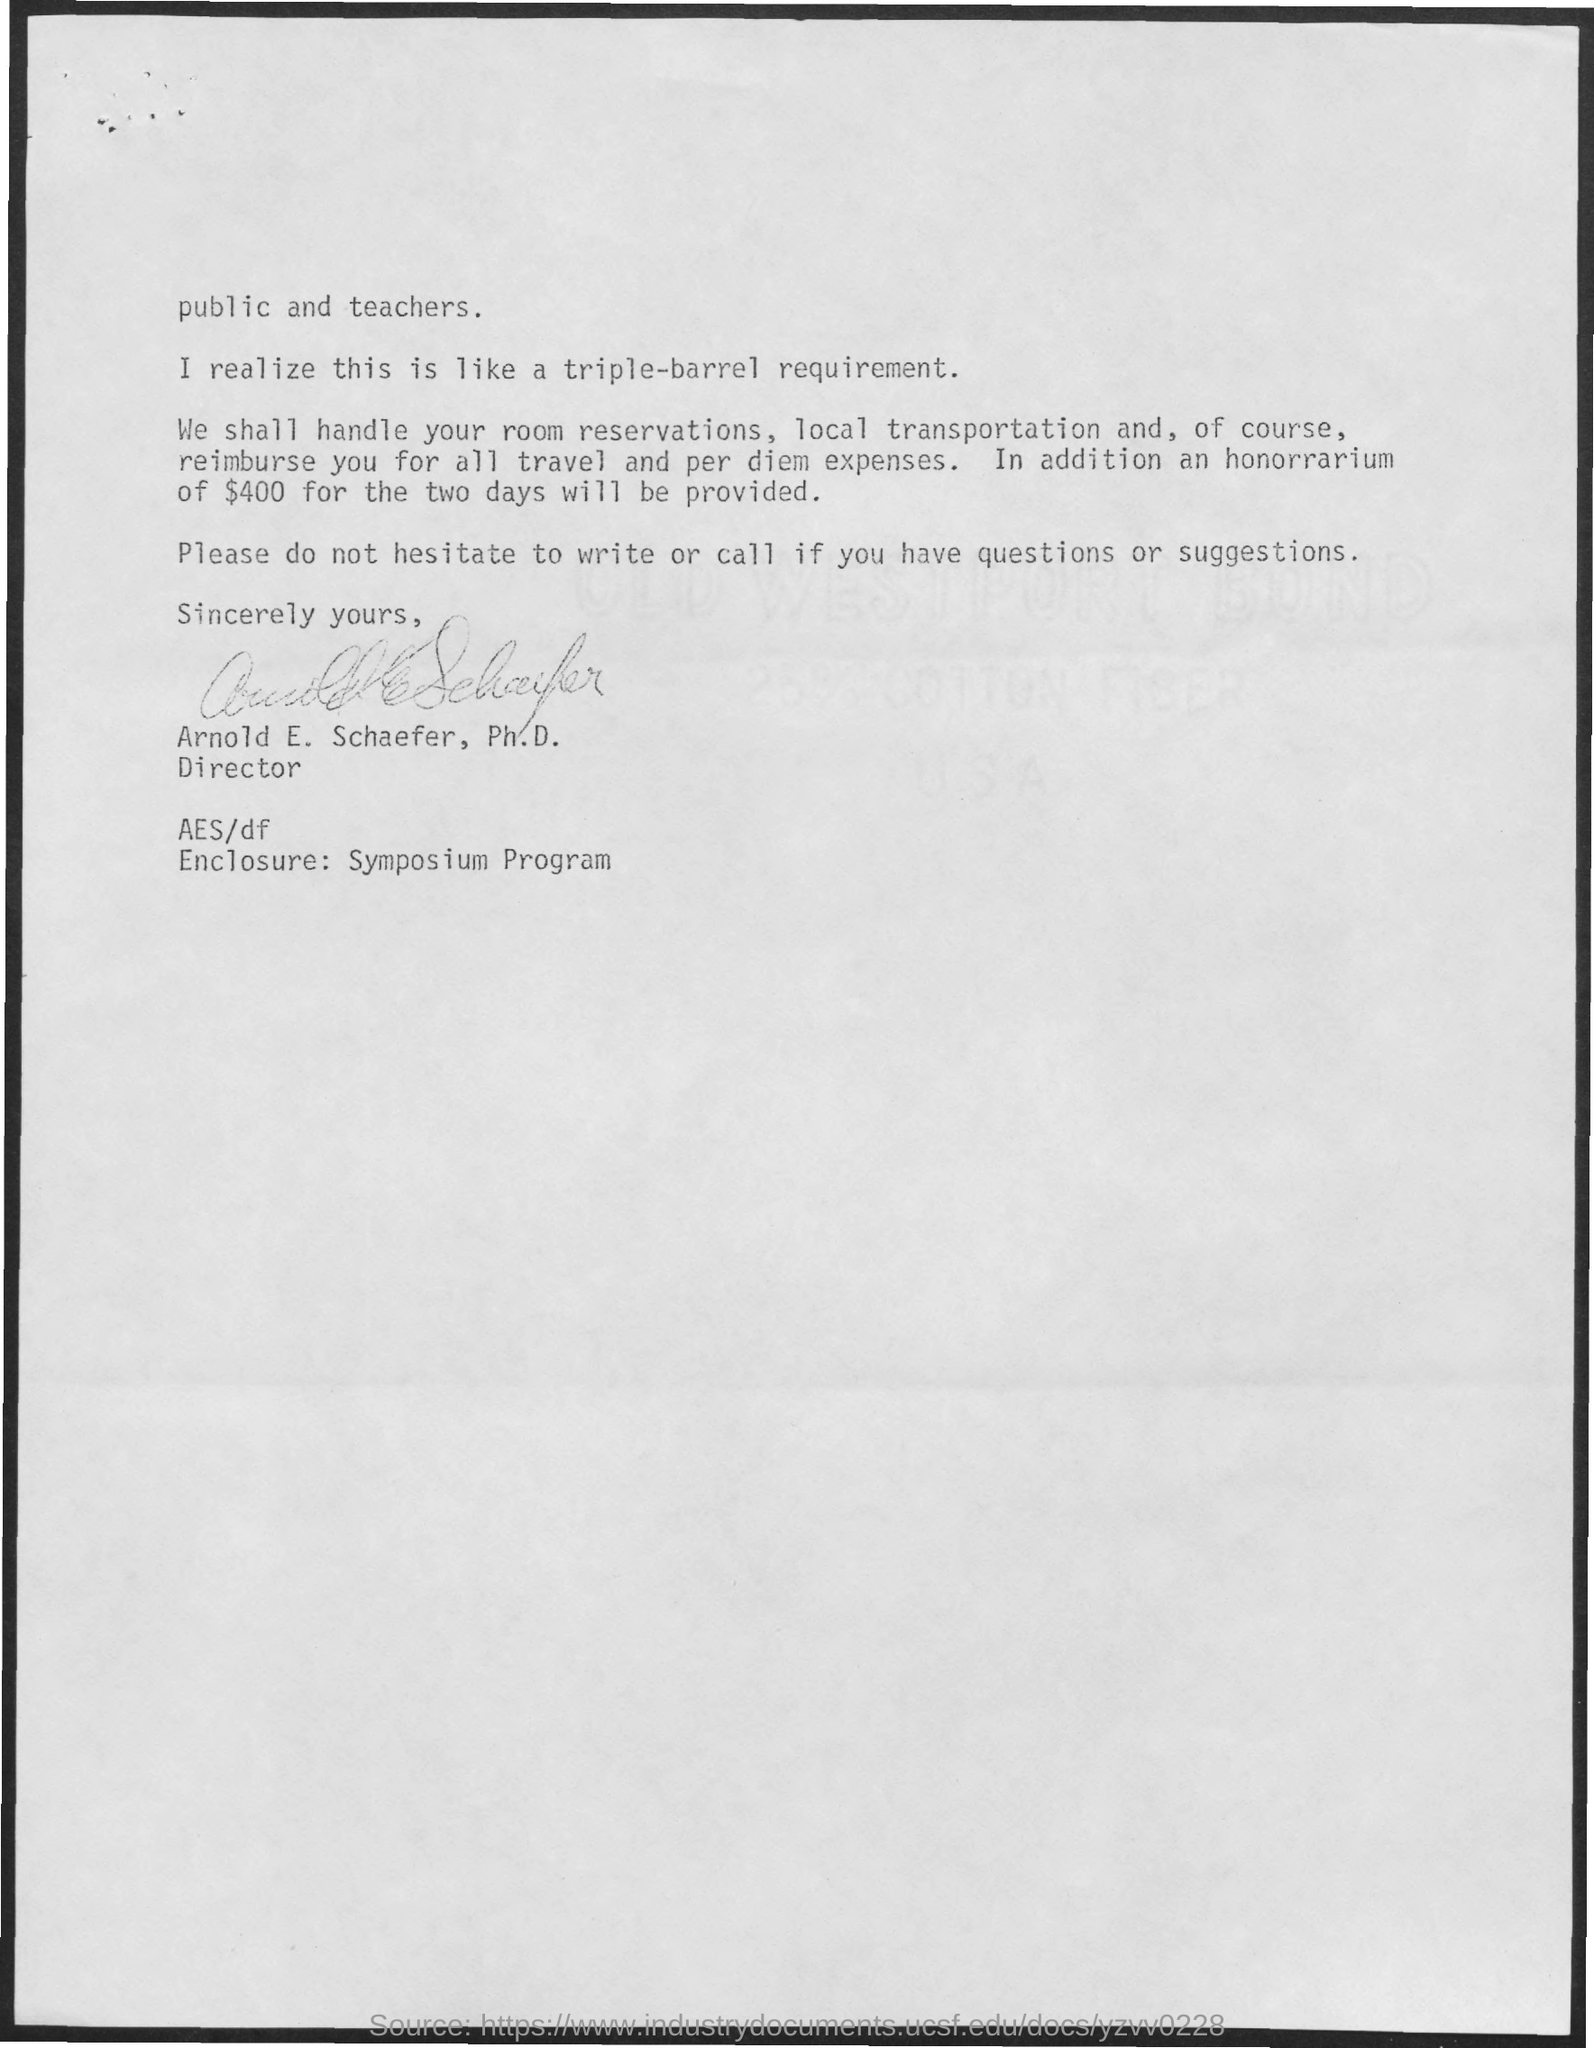How much will be provided as honorarium for two days?
Ensure brevity in your answer.  $400. Who has signed the letter?
Offer a very short reply. Arnold e. Schaefer, Ph.d. What is the enclosure?
Give a very brief answer. Symposium program. 